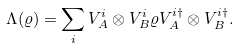<formula> <loc_0><loc_0><loc_500><loc_500>\Lambda ( \varrho ) = \sum _ { i } V _ { A } ^ { i } \otimes V _ { B } ^ { i } \varrho V _ { A } ^ { i \dagger } \otimes V _ { B } ^ { i \dagger } .</formula> 